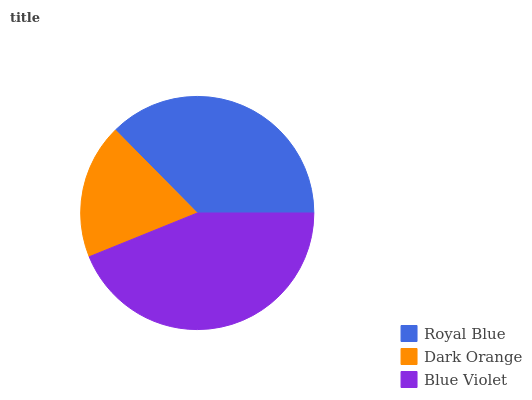Is Dark Orange the minimum?
Answer yes or no. Yes. Is Blue Violet the maximum?
Answer yes or no. Yes. Is Blue Violet the minimum?
Answer yes or no. No. Is Dark Orange the maximum?
Answer yes or no. No. Is Blue Violet greater than Dark Orange?
Answer yes or no. Yes. Is Dark Orange less than Blue Violet?
Answer yes or no. Yes. Is Dark Orange greater than Blue Violet?
Answer yes or no. No. Is Blue Violet less than Dark Orange?
Answer yes or no. No. Is Royal Blue the high median?
Answer yes or no. Yes. Is Royal Blue the low median?
Answer yes or no. Yes. Is Blue Violet the high median?
Answer yes or no. No. Is Dark Orange the low median?
Answer yes or no. No. 